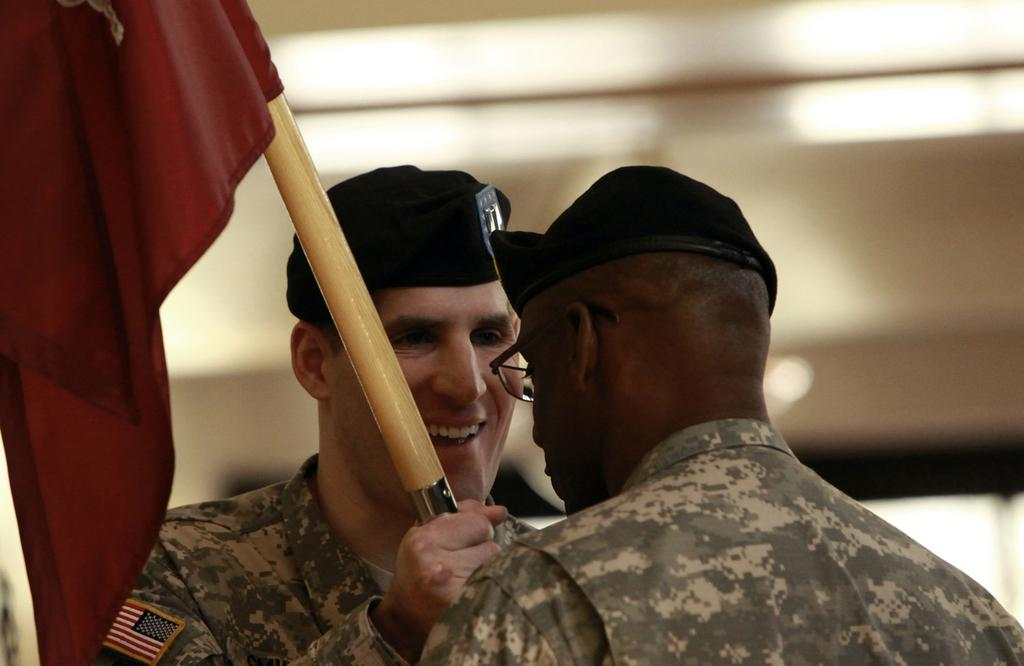What is the primary subject of the image? The primary subject of the image is men. What is one of the men doing in the image? One of the men is holding a flag in his hands. What type of fly can be seen buzzing around the flag in the image? There is no fly present in the image, and therefore no such activity can be observed. 